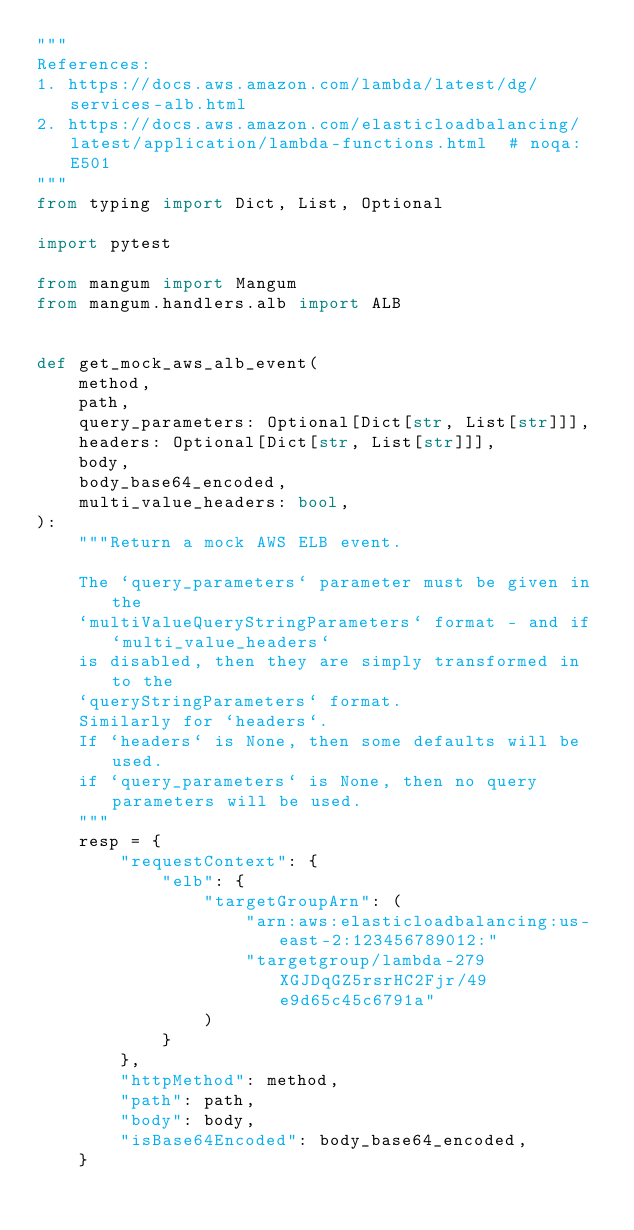<code> <loc_0><loc_0><loc_500><loc_500><_Python_>"""
References:
1. https://docs.aws.amazon.com/lambda/latest/dg/services-alb.html
2. https://docs.aws.amazon.com/elasticloadbalancing/latest/application/lambda-functions.html  # noqa: E501
"""
from typing import Dict, List, Optional

import pytest

from mangum import Mangum
from mangum.handlers.alb import ALB


def get_mock_aws_alb_event(
    method,
    path,
    query_parameters: Optional[Dict[str, List[str]]],
    headers: Optional[Dict[str, List[str]]],
    body,
    body_base64_encoded,
    multi_value_headers: bool,
):
    """Return a mock AWS ELB event.

    The `query_parameters` parameter must be given in the
    `multiValueQueryStringParameters` format - and if `multi_value_headers`
    is disabled, then they are simply transformed in to the
    `queryStringParameters` format.
    Similarly for `headers`.
    If `headers` is None, then some defaults will be used.
    if `query_parameters` is None, then no query parameters will be used.
    """
    resp = {
        "requestContext": {
            "elb": {
                "targetGroupArn": (
                    "arn:aws:elasticloadbalancing:us-east-2:123456789012:"
                    "targetgroup/lambda-279XGJDqGZ5rsrHC2Fjr/49e9d65c45c6791a"
                )
            }
        },
        "httpMethod": method,
        "path": path,
        "body": body,
        "isBase64Encoded": body_base64_encoded,
    }
</code> 